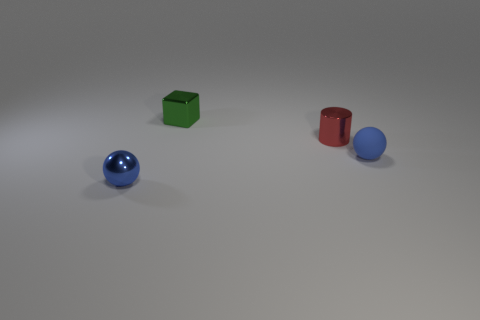What is the color of the cylinder that is the same size as the metal cube?
Your answer should be compact. Red. How many small green metal things are behind the ball that is left of the green metallic block?
Make the answer very short. 1. What number of objects are either spheres to the left of the tiny green block or cylinders?
Provide a succinct answer. 2. How many small gray balls are the same material as the small red object?
Offer a very short reply. 0. What is the shape of the other tiny thing that is the same color as the rubber object?
Make the answer very short. Sphere. Are there the same number of green metallic blocks that are in front of the small green shiny cube and rubber balls?
Your answer should be very brief. No. What number of large things are brown blocks or blocks?
Your response must be concise. 0. What color is the other object that is the same shape as the rubber thing?
Provide a succinct answer. Blue. Is the metal sphere the same size as the matte object?
Offer a terse response. Yes. How many things are either red objects or small blue objects that are on the right side of the red metal object?
Make the answer very short. 2. 